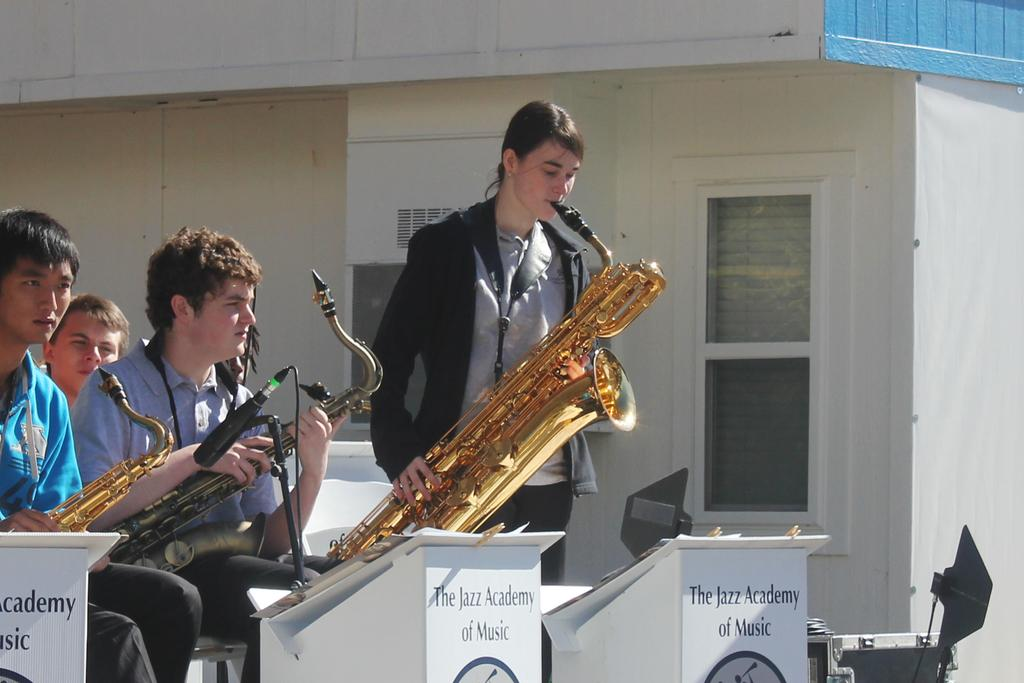<image>
Share a concise interpretation of the image provided. The Jazz Academy of Music features several young talented saxophone players. 